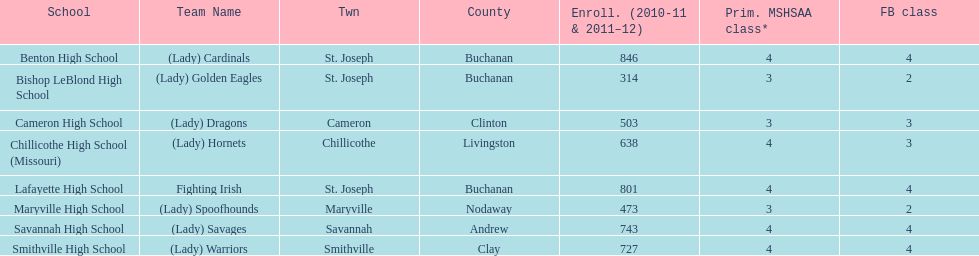What is the number of football classes lafayette high school has? 4. Would you be able to parse every entry in this table? {'header': ['School', 'Team Name', 'Twn', 'County', 'Enroll. (2010-11 & 2011–12)', 'Prim. MSHSAA class*', 'FB class'], 'rows': [['Benton High School', '(Lady) Cardinals', 'St. Joseph', 'Buchanan', '846', '4', '4'], ['Bishop LeBlond High School', '(Lady) Golden Eagles', 'St. Joseph', 'Buchanan', '314', '3', '2'], ['Cameron High School', '(Lady) Dragons', 'Cameron', 'Clinton', '503', '3', '3'], ['Chillicothe High School (Missouri)', '(Lady) Hornets', 'Chillicothe', 'Livingston', '638', '4', '3'], ['Lafayette High School', 'Fighting Irish', 'St. Joseph', 'Buchanan', '801', '4', '4'], ['Maryville High School', '(Lady) Spoofhounds', 'Maryville', 'Nodaway', '473', '3', '2'], ['Savannah High School', '(Lady) Savages', 'Savannah', 'Andrew', '743', '4', '4'], ['Smithville High School', '(Lady) Warriors', 'Smithville', 'Clay', '727', '4', '4']]} 